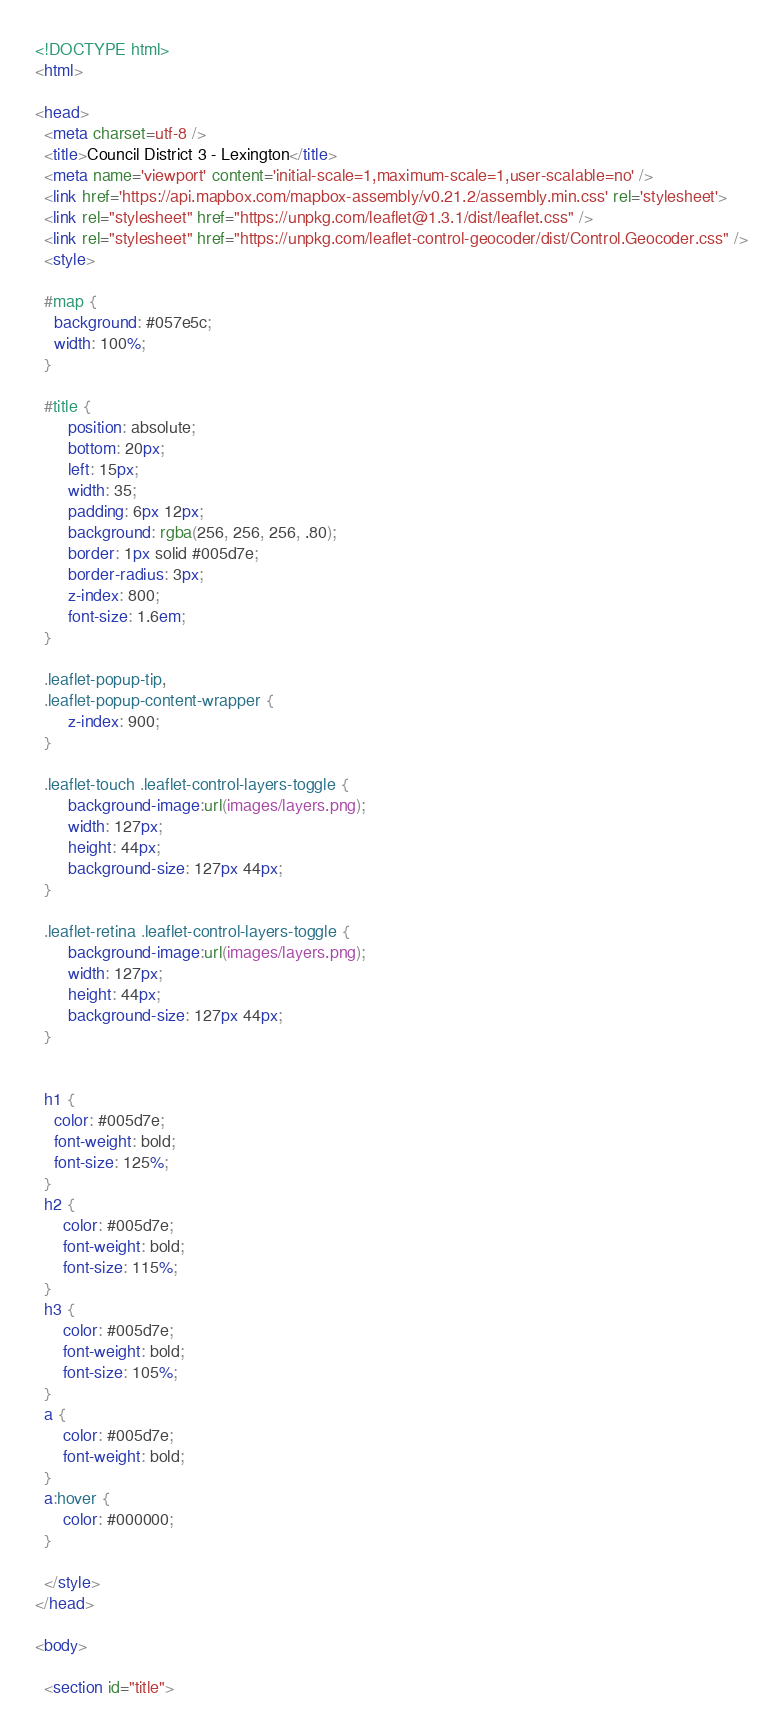Convert code to text. <code><loc_0><loc_0><loc_500><loc_500><_HTML_><!DOCTYPE html>
<html>

<head>
  <meta charset=utf-8 />
  <title>Council District 3 - Lexington</title>
  <meta name='viewport' content='initial-scale=1,maximum-scale=1,user-scalable=no' />
  <link href='https://api.mapbox.com/mapbox-assembly/v0.21.2/assembly.min.css' rel='stylesheet'>
  <link rel="stylesheet" href="https://unpkg.com/leaflet@1.3.1/dist/leaflet.css" />
  <link rel="stylesheet" href="https://unpkg.com/leaflet-control-geocoder/dist/Control.Geocoder.css" />
  <style>

  #map {
    background: #057e5c;
    width: 100%;
  }

  #title {
       position: absolute;
       bottom: 20px;
       left: 15px;
       width: 35;
       padding: 6px 12px;
       background: rgba(256, 256, 256, .80);
       border: 1px solid #005d7e;
       border-radius: 3px;
       z-index: 800;
       font-size: 1.6em;
  }

  .leaflet-popup-tip,
  .leaflet-popup-content-wrapper {
       z-index: 900;
  }

  .leaflet-touch .leaflet-control-layers-toggle {
       background-image:url(images/layers.png);
       width: 127px;
       height: 44px;
       background-size: 127px 44px;
  }

  .leaflet-retina .leaflet-control-layers-toggle {
       background-image:url(images/layers.png);
       width: 127px;
       height: 44px;
       background-size: 127px 44px;
  }


  h1 {
    color: #005d7e;
    font-weight: bold;
    font-size: 125%;
  }
  h2 {
      color: #005d7e;
      font-weight: bold;
      font-size: 115%;
  }
  h3 {
      color: #005d7e;
      font-weight: bold;
      font-size: 105%;
  }
  a {
      color: #005d7e;
      font-weight: bold;
  }
  a:hover {
      color: #000000;
  }

  </style>
</head>

<body>

  <section id="title"></code> 